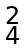Convert formula to latex. <formula><loc_0><loc_0><loc_500><loc_500>\begin{smallmatrix} 2 \\ 4 \\ \end{smallmatrix}</formula> 